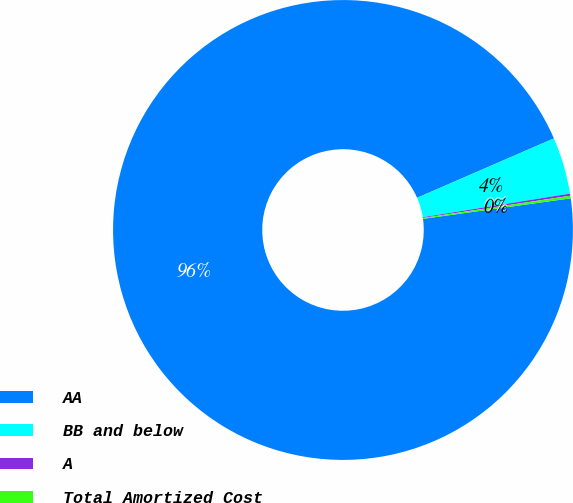<chart> <loc_0><loc_0><loc_500><loc_500><pie_chart><fcel>AA<fcel>BB and below<fcel>A<fcel>Total Amortized Cost<nl><fcel>95.67%<fcel>3.99%<fcel>0.15%<fcel>0.18%<nl></chart> 